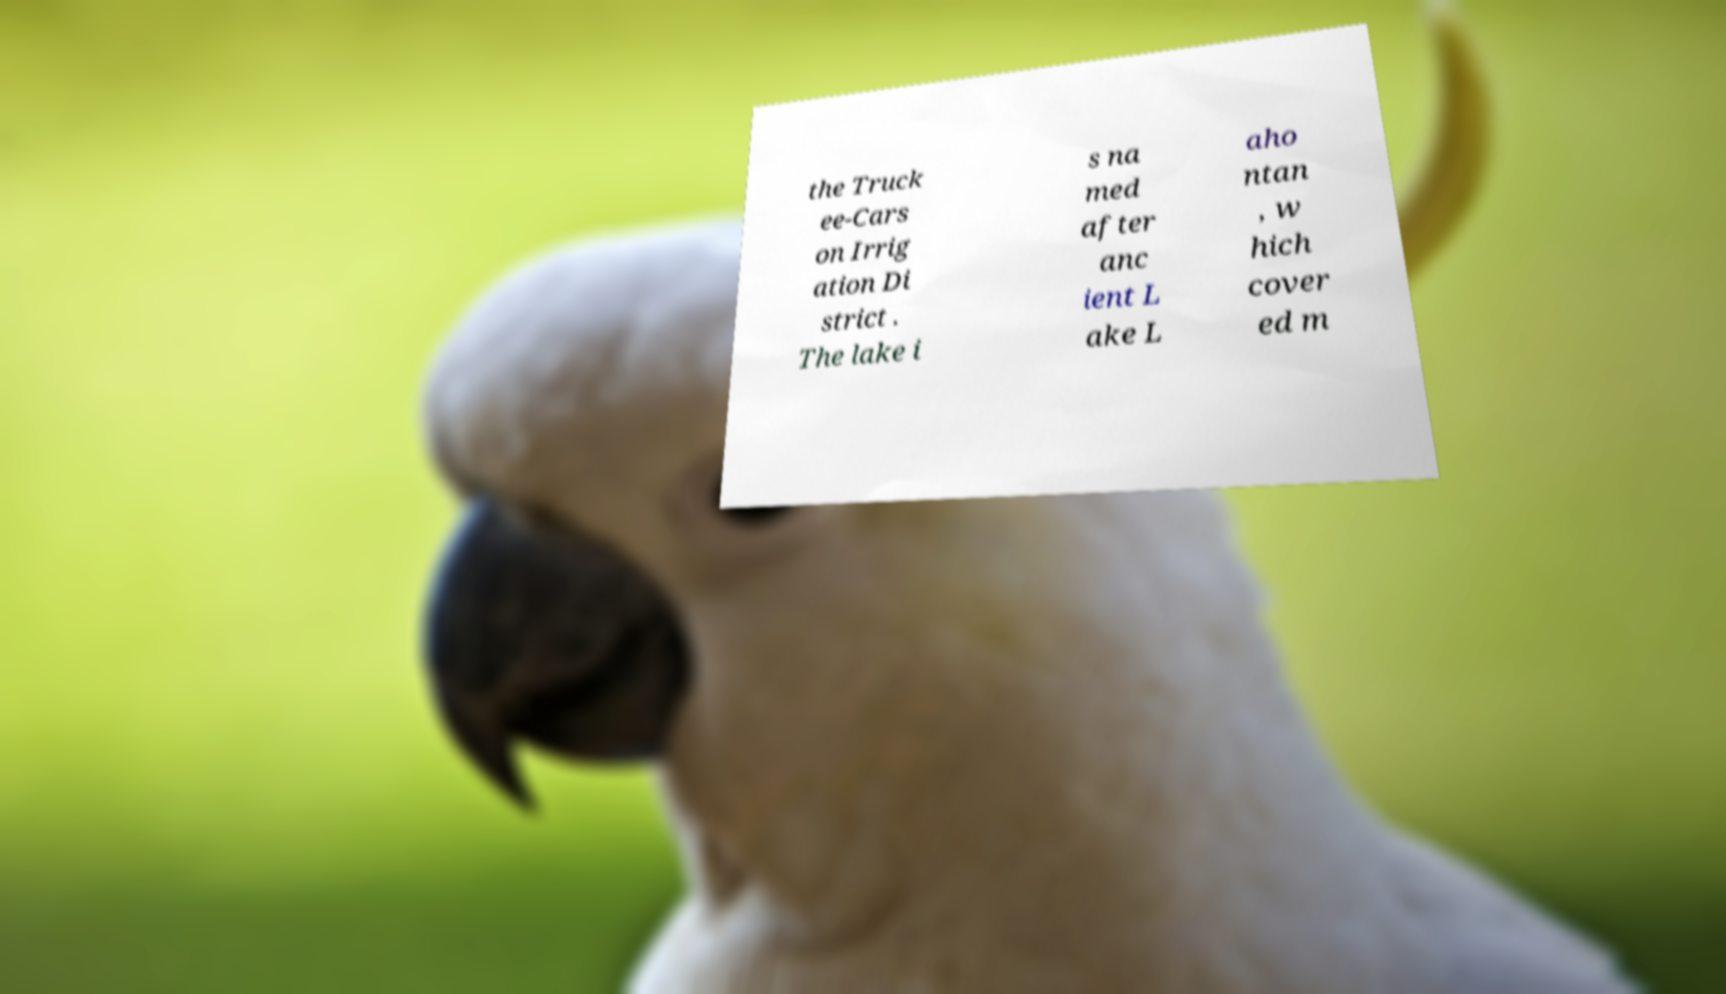Can you read and provide the text displayed in the image?This photo seems to have some interesting text. Can you extract and type it out for me? the Truck ee-Cars on Irrig ation Di strict . The lake i s na med after anc ient L ake L aho ntan , w hich cover ed m 